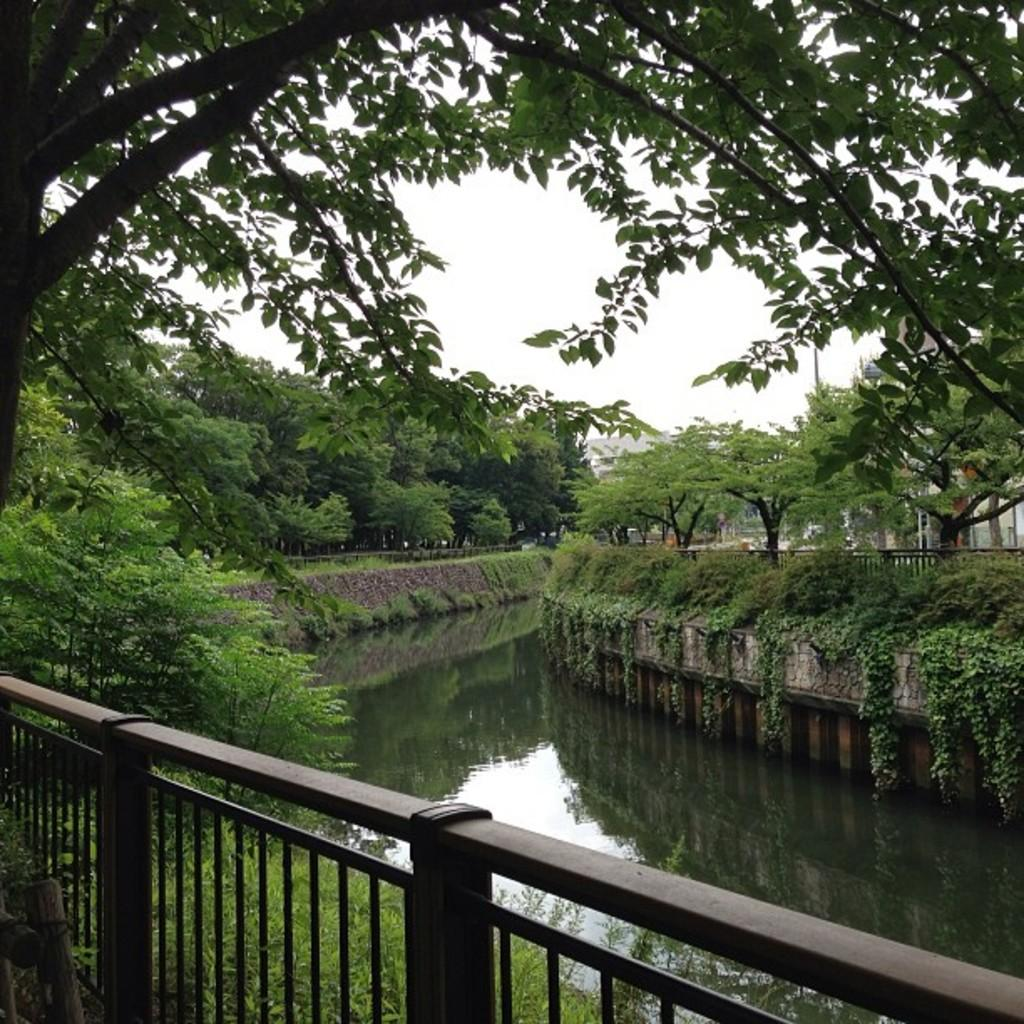What type of barrier can be seen in the image? There is a fence in the image. What type of vegetation is present in the image? There is grass in the image. What natural element can be seen in the image? There is water visible in the image. What can be seen in the background of the image? There are trees, plants, and the sky visible in the background of the image. What color is the square hook in the image? There is no square hook present in the image. What type of color is used to paint the trees in the background? The provided facts do not mention the color of the trees; only their presence is noted. 